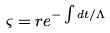<formula> <loc_0><loc_0><loc_500><loc_500>\varsigma = r e ^ { - \int d t / \Lambda }</formula> 